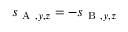<formula> <loc_0><loc_0><loc_500><loc_500>s _ { A , y , z } = - s _ { B , y , z }</formula> 